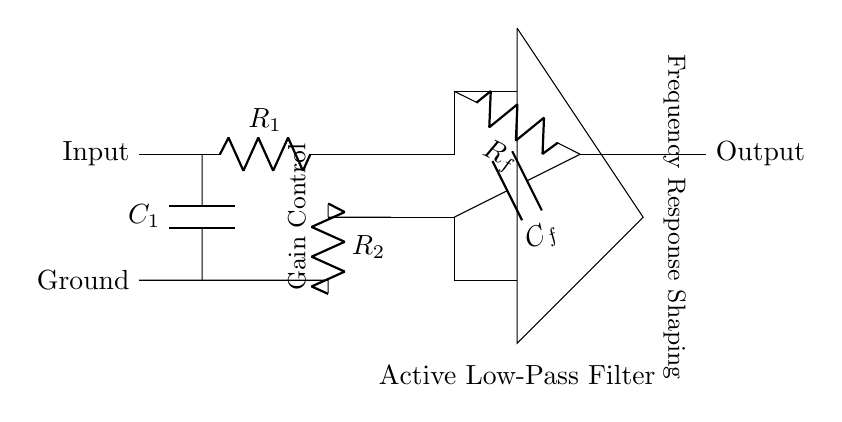What type of filter is represented in the circuit? The circuit is labeled as an "Active Low-Pass Filter," indicating its type based on the given information in the diagram.
Answer: Active Low-Pass Filter What are the values of the resistors in the circuit? The resistors are labeled as R1, R2, and Rf without specific numerical values; however, they are essential components of the circuit.
Answer: R1, R2, Rf What is the function of capacitor C1 in this circuit? C1 is positioned at the input side; it typically serves to block DC while allowing AC signals to pass through, functioning in the filtering process.
Answer: Coupling How does the feedback from Rf affect gain? The feedback resistor Rf is connected to the output and influences the gain of the circuit by determining how much of the output is fed back into the inverting input, thus regulating the amplification.
Answer: Gain Control How does capacitor Cf influence the circuit's frequency response? The capacitor Cf is part of the feedback path; its value, in combination with Rf, will influence the cutoff frequency and the behavior of the circuit at different frequencies, shaping the frequency response.
Answer: Frequency Response Shaping Which components are pivotal for shaping the frequency response? The components Rf and Cf directly interact to shape the frequency response, defining the cutoff frequency and affecting how the circuit responds to varying frequencies.
Answer: Rf, Cf 